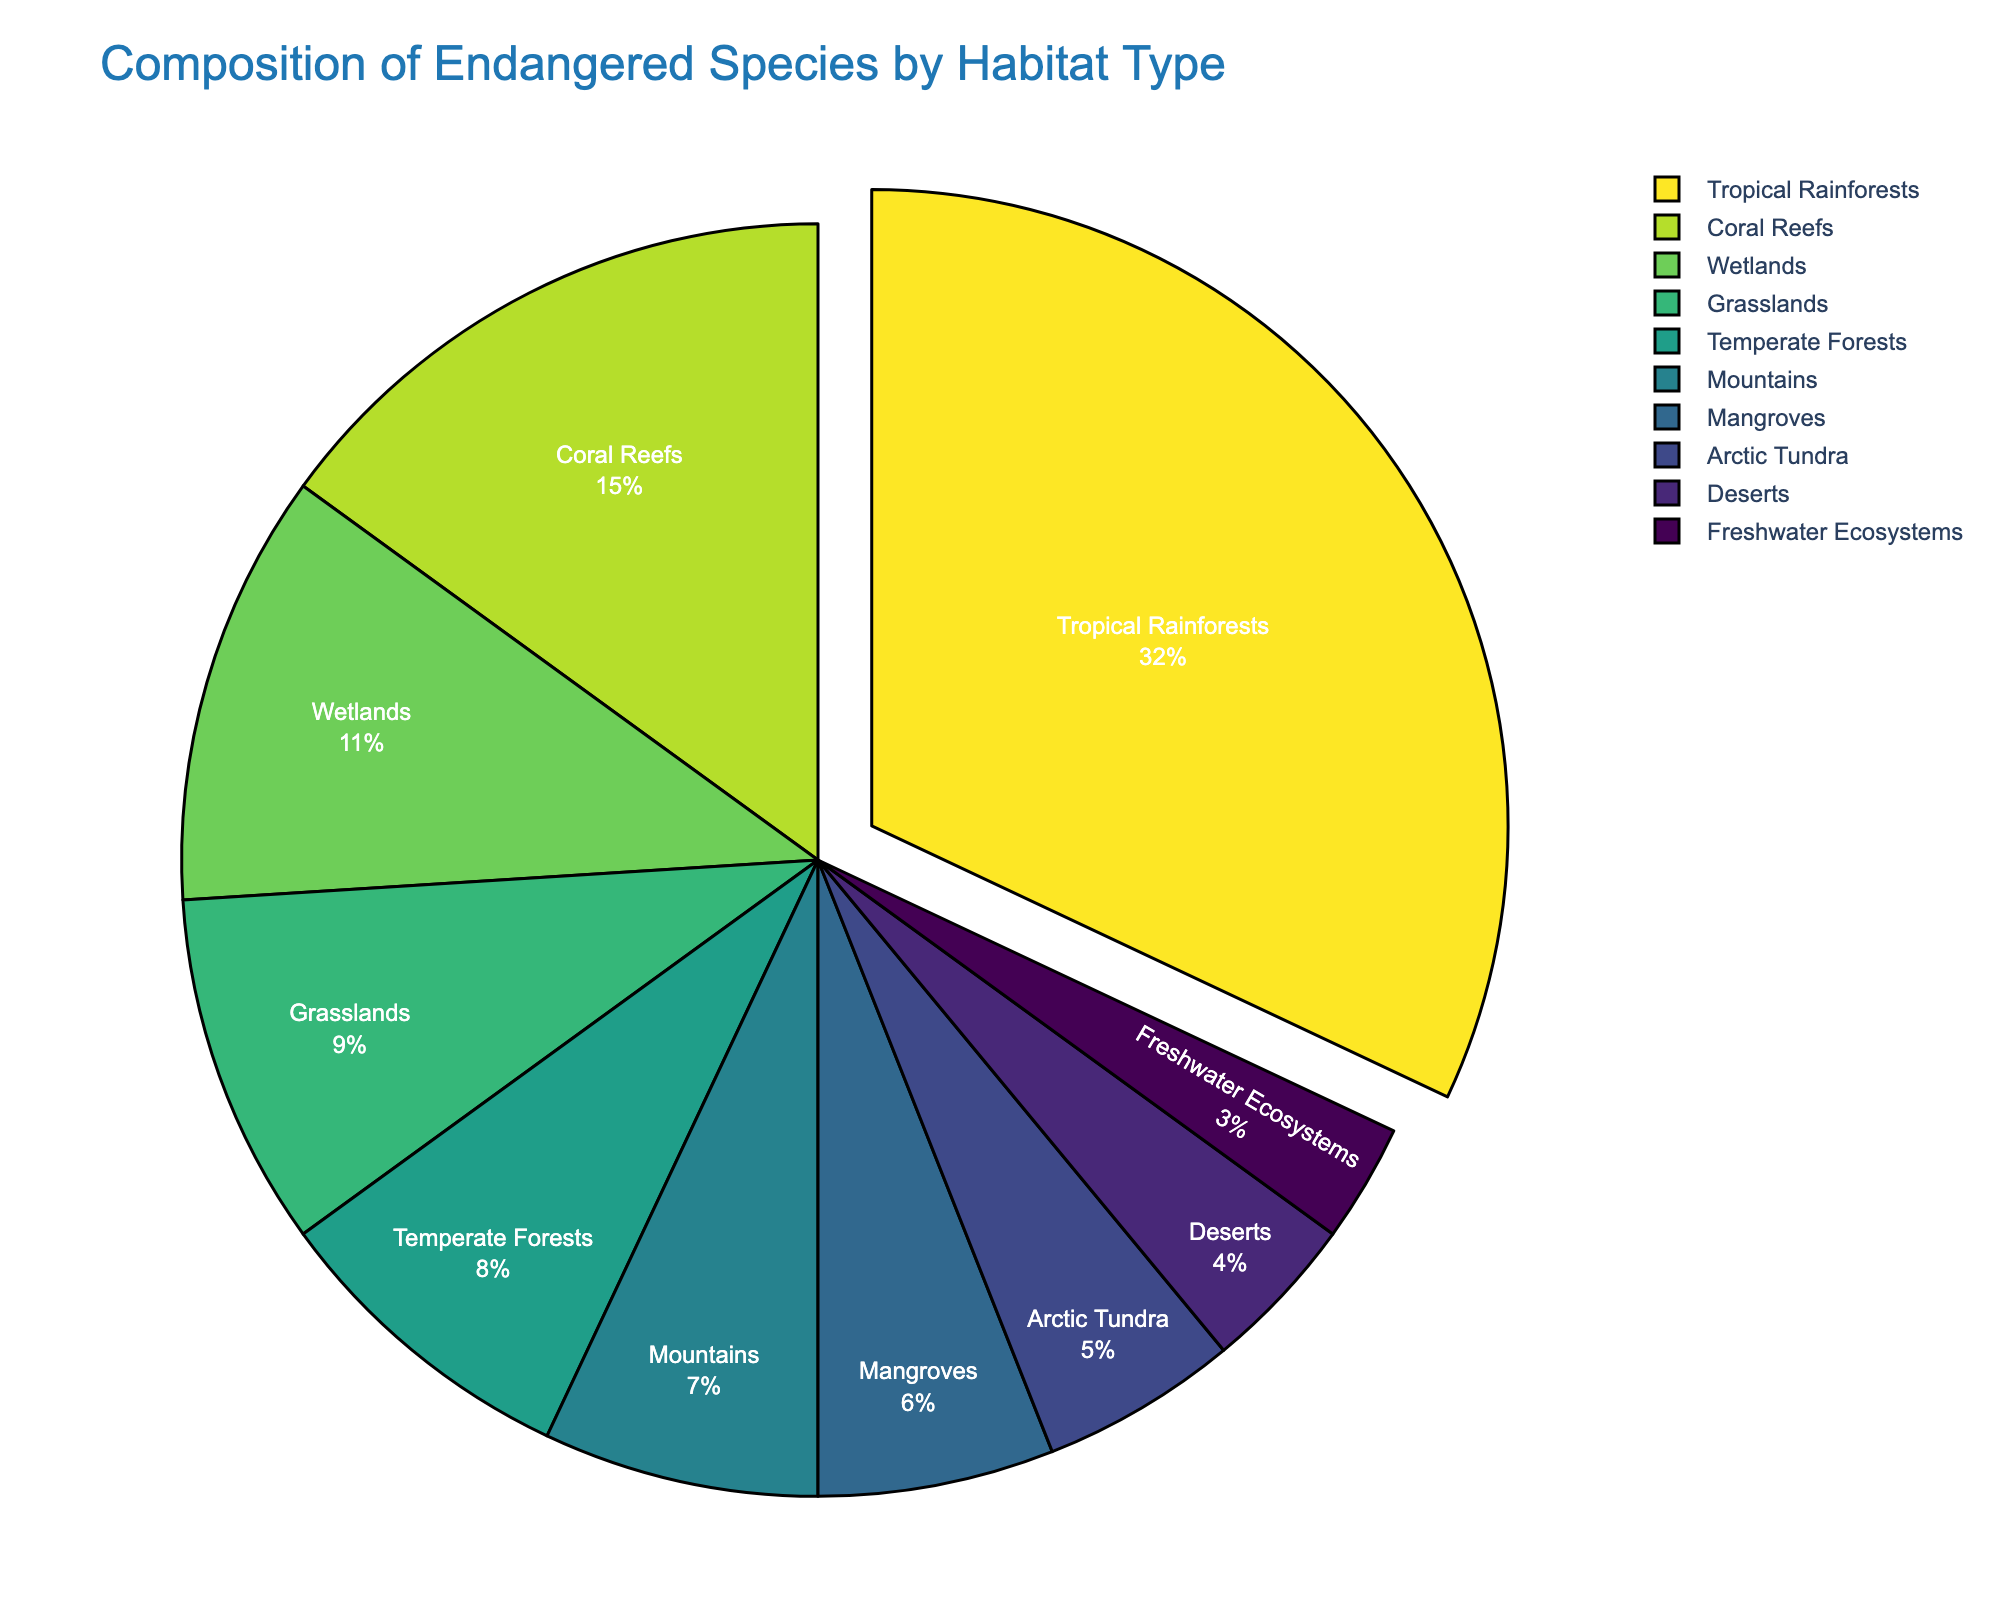Which habitat type has the largest percentage of endangered species? By looking at the pie chart, we can easily identify the segment taking up the largest portion of the pie.
Answer: Tropical Rainforests Which habitat types have a combined percentage of endangered species that exceeds 50%? We add the percentages of the habitat types from largest to smallest until the sum exceeds 50%. Tropical Rainforests (32%) + Coral Reefs (15%) = 47%, adding Wetlands (11%) exceeds 50%.
Answer: Tropical Rainforests, Coral Reefs, Wetlands Which habitat type has the smallest percentage of endangered species and what is the percentage? By looking at the pie chart, we can identify the smallest segment.
Answer: Freshwater Ecosystems, 3% By how much does the percentage of endangered species in Tropical Rainforests exceed that in Coral Reefs? We subtract the percentage of Coral Reefs from that of Tropical Rainforests (32% - 15%).
Answer: 17% Are there more endangered species in Temperate Forests or Wetlands? By comparing the sizes of the respective segments in the pie chart, we see that Wetlands is larger than Temperate Forests.
Answer: Wetlands What is the combined percentage of endangered species found in Grasslands and Deserts? We add the percentages of both habitat types (9% + 4%).
Answer: 13% Which habitat type makes up approximately 10% of the endangered species' habitat composition? By looking at the pie chart, we identify the segment closest to 10%, which is Grasslands.
Answer: Grasslands Which two habitat types combined have about the same percentage of endangered species as Tropical Rainforests? We look for two smaller segments that add up to approximately 32%. Coral Reefs (15%) and Wetlands (11%) combined is 26%, but adding Mountains (7%) makes it 33%, which is close.
Answer: Coral Reefs and Wetlands What is the visual feature of the segment representing the habitat type with the highest percentage of endangered species? The segment for Tropical Rainforests is slightly pulled out from the pie chart to highlight it.
Answer: Pulled out segment How does the proportion of endangered species in Mangroves compare to that in Arctic Tundra? By comparing the segment sizes in the pie chart, we see that Mangroves (6%) have a slightly larger proportion than Arctic Tundra (5%).
Answer: Mangroves have a slightly larger proportion 